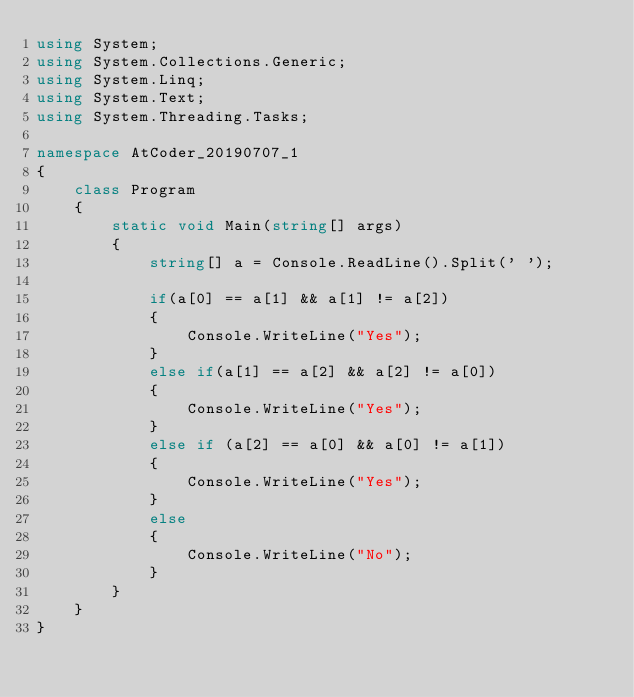<code> <loc_0><loc_0><loc_500><loc_500><_C#_>using System;
using System.Collections.Generic;
using System.Linq;
using System.Text;
using System.Threading.Tasks;

namespace AtCoder_20190707_1
{
    class Program
    {
        static void Main(string[] args)
        {
            string[] a = Console.ReadLine().Split(' ');

            if(a[0] == a[1] && a[1] != a[2])
            {
                Console.WriteLine("Yes");
            }
            else if(a[1] == a[2] && a[2] != a[0])
            {
                Console.WriteLine("Yes");
            }
            else if (a[2] == a[0] && a[0] != a[1])
            {
                Console.WriteLine("Yes");
            }
            else
            {
                Console.WriteLine("No");
            }
        }
    }
}
</code> 